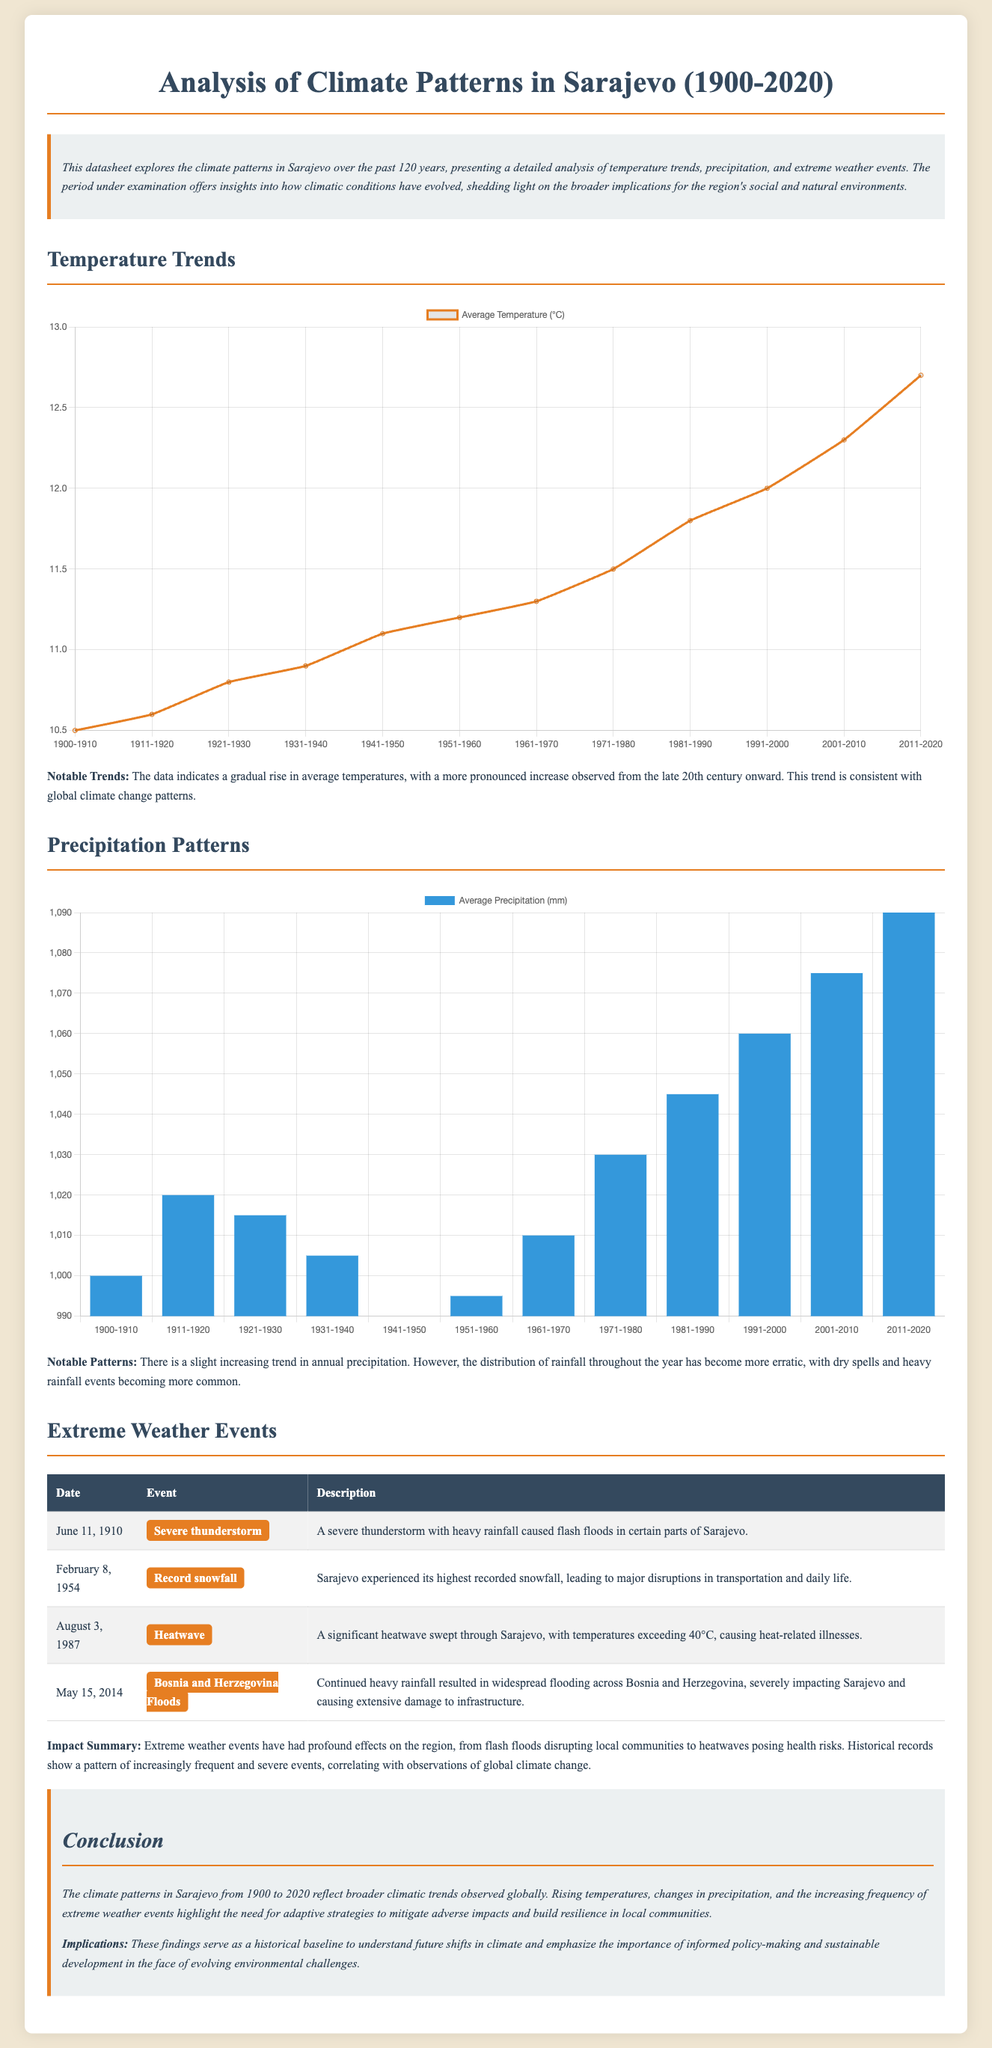What is the average temperature in 2020? The average temperature in 2020 is the last data point in the temperature trends section, which is 12.7°C.
Answer: 12.7°C What significant weather event occurred on February 8, 1954? The event details indicate that the highest recorded snowfall occurred on this date, leading to major disruptions.
Answer: Record snowfall What was the average precipitation from 1911 to 1920? The average precipitation for that decade is included in the precipitation patterns section, which is 1020 mm.
Answer: 1020 mm Which year did Sarajevo experience a severe thunderstorm? The document lists June 11, 1910, as the date of the severe thunderstorm event.
Answer: June 11, 1910 What is the trend observed for annual precipitation throughout the years? The document states there is a slight increasing trend, but the distribution has become more erratic.
Answer: Slight increasing trend What notable temperature increase trend is mentioned from the late 20th century? The document states a more pronounced increase is observed from this period onward.
Answer: More pronounced increase How many extreme weather events are listed in the document? The document presents a table with four specific extreme weather events detailed.
Answer: Four What is the main implication highlighted in the conclusion? The conclusion emphasizes the need for adaptive strategies to mitigate adverse impacts.
Answer: Adaptive strategies When did the heatwave with temperatures exceeding 40°C occur? The document points out that this significant heatwave occurred on August 3, 1987.
Answer: August 3, 1987 